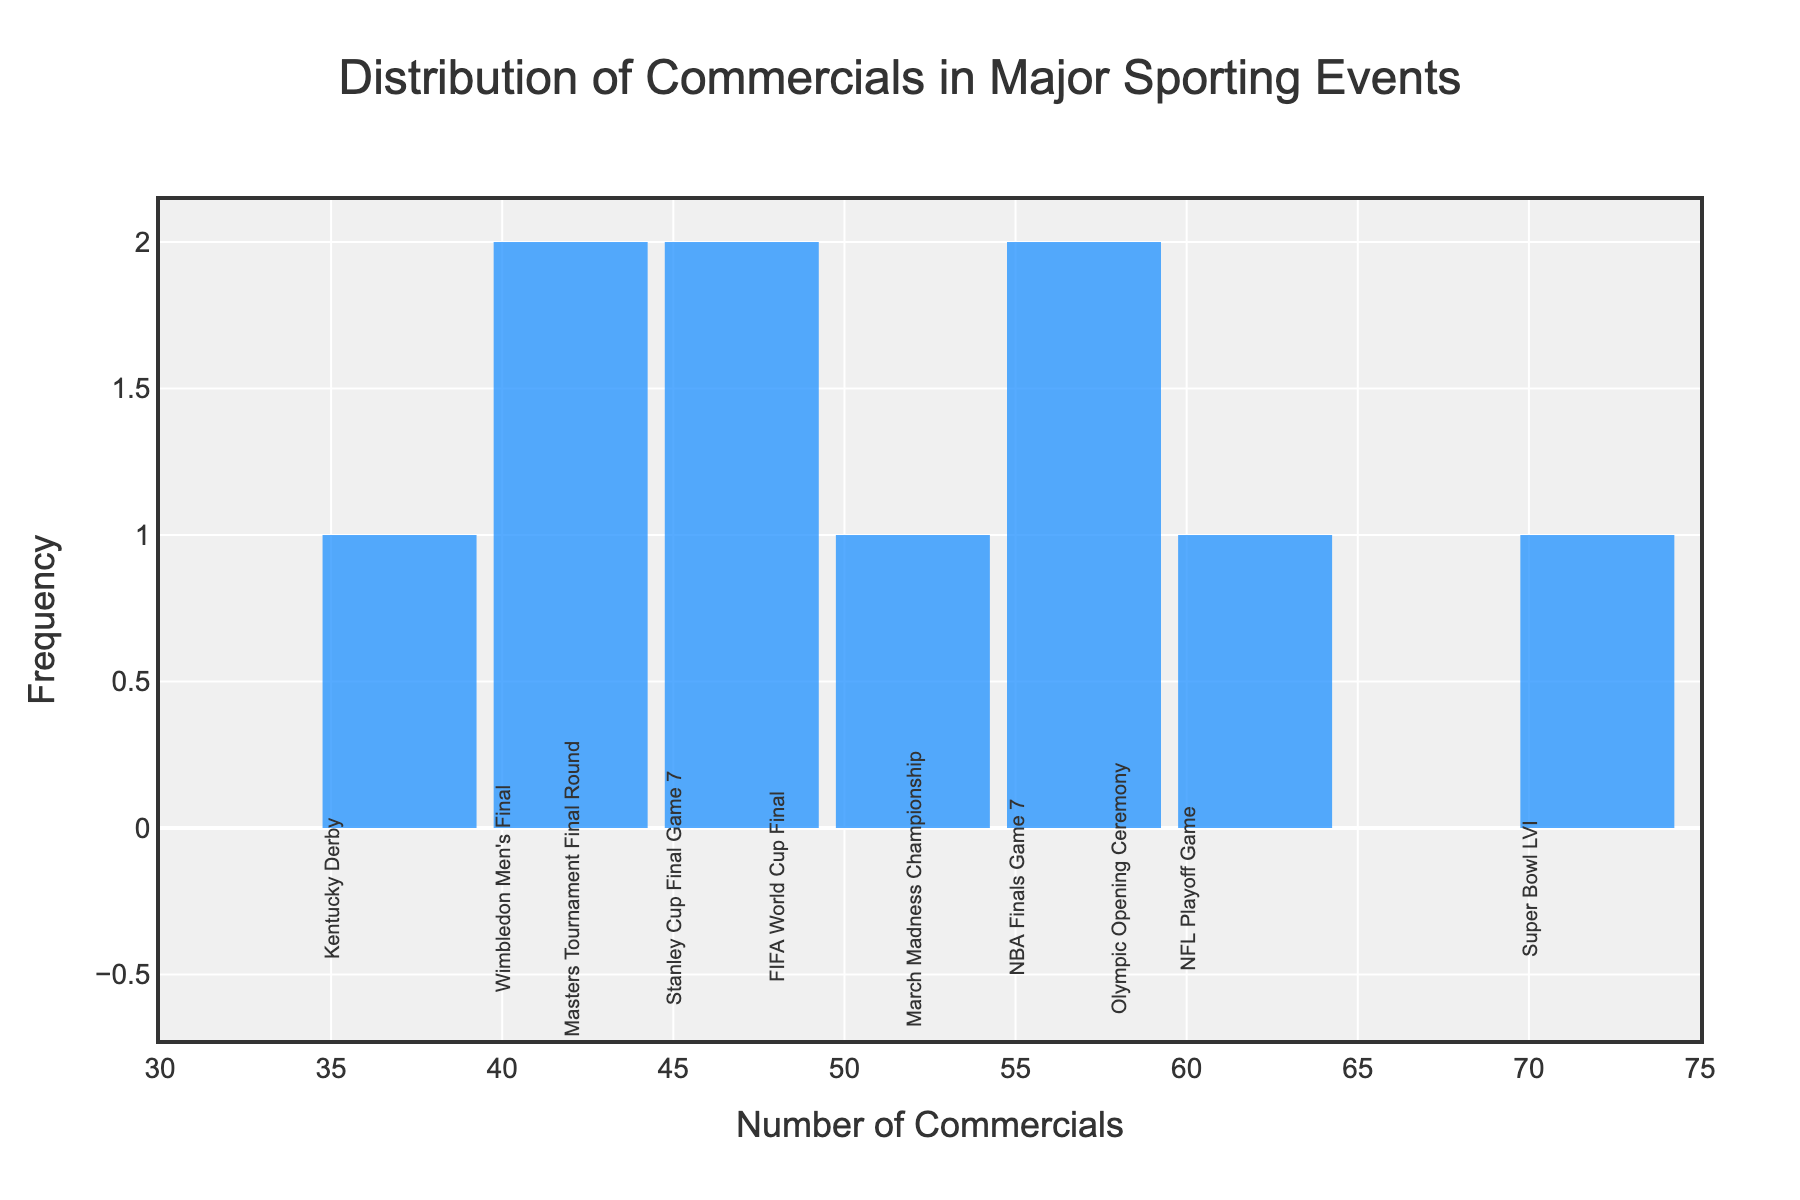What is the title of the plot? The title of the plot is located at the top center and reads "Distribution of Commercials in Major Sporting Events".
Answer: Distribution of Commercials in Major Sporting Events What is the range of the x-axis? The x-axis represents the number of commercials and ranges from 30 to 75. This is indicated by the axis tick labels.
Answer: 30 to 75 Which event had the most commercials? By looking at the annotations for each bar, the Super Bowl LVI had the highest number of commercials, positioned at the rightmost bar.
Answer: Super Bowl LVI What is the color used for the bars in the histogram? The bars in the histogram are colored in blue. This can be inferred from the marker color of the bars.
Answer: Blue How many events are represented in total? There are 10 events represented in the histogram, inferred by counting the annotations for each bar.
Answer: 10 What is the average number of commercials aired across these events? To find the average, sum the number of commercials for all events (70 + 55 + 48 + 40 + 35 + 60 + 52 + 45 + 58 + 42 = 505) and divide by the number of events (10).
Answer: 50.5 Which event had the least number of commercials? By referring to the annotations, the Kentucky Derby had the fewest commercials with 35.
Answer: Kentucky Derby How many times does the number of commercials fall between 50 and 60? Identify the bars whose commercial numbers fall between 50 and 60: Super Bowl LVI, NBA Finals Game 7, Olympic Opening Ceremony, and March Madness Championship. There are 4 events in this range.
Answer: 4 What is the most frequent range interval for the number of commercials? The histogram bar that appears most frequently falls within the range of 40 to 50 commercials as it includes Wimbledon Men's Final, Stanley Cup Final Game 7, and Masters Tournament Final Round.
Answer: 40 to 50 commercials Which events had more than 55 commercials? Identify the events with bars annotated above 55 commercials: Super Bowl LVI (70), NFL Playoff Game (60), and Olympic Opening Ceremony (58).
Answer: Super Bowl LVI, NFL Playoff Game, and Olympic Opening Ceremony 